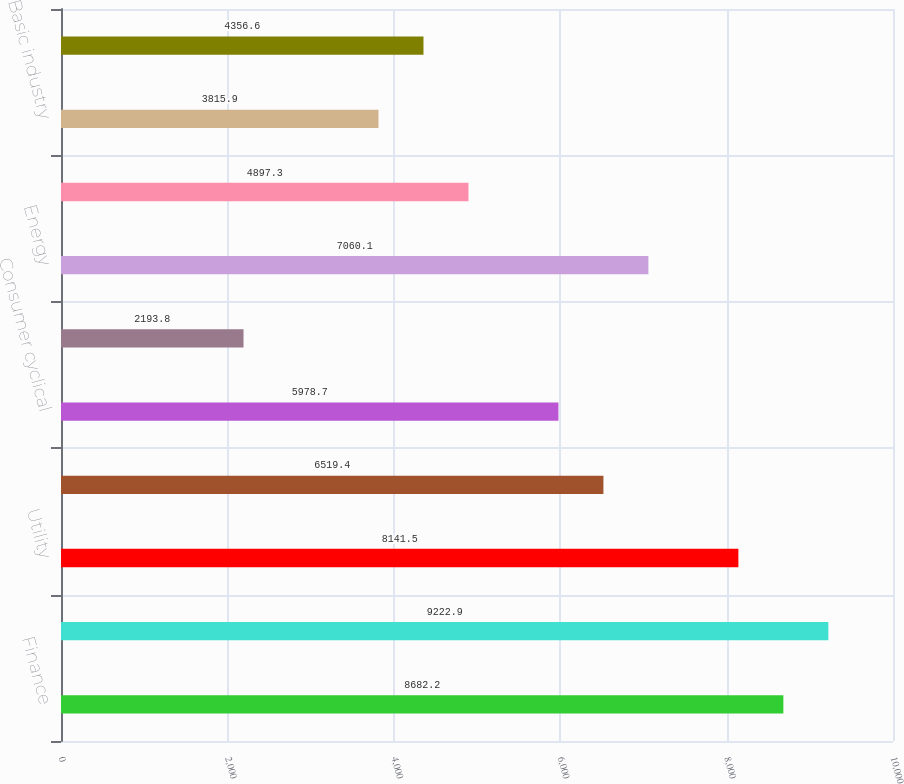Convert chart to OTSL. <chart><loc_0><loc_0><loc_500><loc_500><bar_chart><fcel>Finance<fcel>Consumer non-cyclical<fcel>Utility<fcel>Capital goods<fcel>Consumer cyclical<fcel>Foreign agencies<fcel>Energy<fcel>Communications<fcel>Basic industry<fcel>Transportation<nl><fcel>8682.2<fcel>9222.9<fcel>8141.5<fcel>6519.4<fcel>5978.7<fcel>2193.8<fcel>7060.1<fcel>4897.3<fcel>3815.9<fcel>4356.6<nl></chart> 